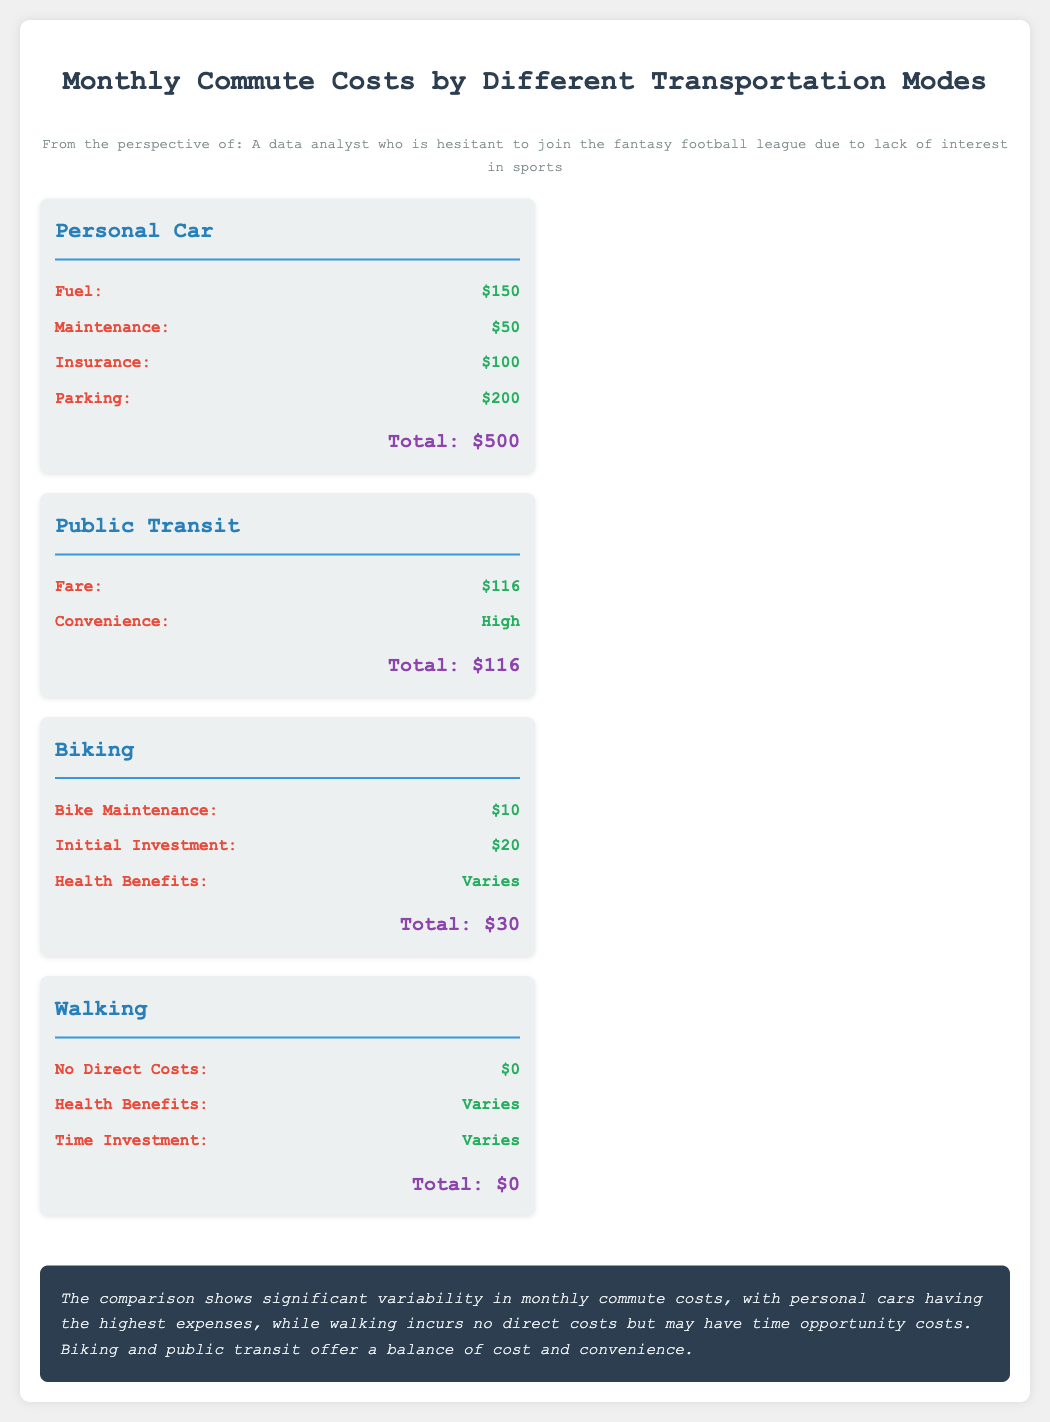What is the total cost for personal car commuting? The total cost for personal car commuting is calculated by adding all expenses related to the personal car, which are Fuel, Maintenance, Insurance, and Parking. The total is $150 + $50 + $100 + $200 = $500.
Answer: $500 What is the fare for public transit? The fare for public transit is explicitly mentioned in the document.
Answer: $116 How much is the bike maintenance cost? The bike maintenance cost is listed in the biking section of the document.
Answer: $10 Which transportation mode has no direct costs? The document clearly states that the walking option incurs no direct costs, making it the mode with no expenses.
Answer: Walking Compare the total cost of biking and public transit. To compare the total cost of biking ($30) with public transit ($116), we can see that public transit is significantly more expensive than biking.
Answer: $116 What aspect of public transit is categorized as 'High'? The document indicates that public transit has a 'High' convenience aspect.
Answer: Convenience What are the health benefits associated with walking? The document states that health benefits from walking may vary, suggesting that there is potential for different impacts on health depending on the individual.
Answer: Varies Which transportation mode has the lowest total cost? The total costs for each mode are compared, and walking has the lowest at $0.
Answer: Walking What is the total monthly cost of biking? The total monthly cost of biking includes bike maintenance and the initial investment. The calculations add up to $10 + $20 = $30.
Answer: $30 